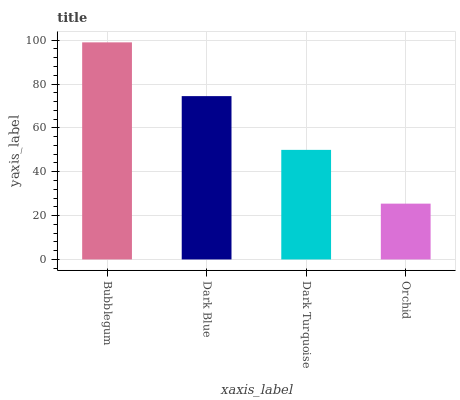Is Orchid the minimum?
Answer yes or no. Yes. Is Bubblegum the maximum?
Answer yes or no. Yes. Is Dark Blue the minimum?
Answer yes or no. No. Is Dark Blue the maximum?
Answer yes or no. No. Is Bubblegum greater than Dark Blue?
Answer yes or no. Yes. Is Dark Blue less than Bubblegum?
Answer yes or no. Yes. Is Dark Blue greater than Bubblegum?
Answer yes or no. No. Is Bubblegum less than Dark Blue?
Answer yes or no. No. Is Dark Blue the high median?
Answer yes or no. Yes. Is Dark Turquoise the low median?
Answer yes or no. Yes. Is Bubblegum the high median?
Answer yes or no. No. Is Orchid the low median?
Answer yes or no. No. 